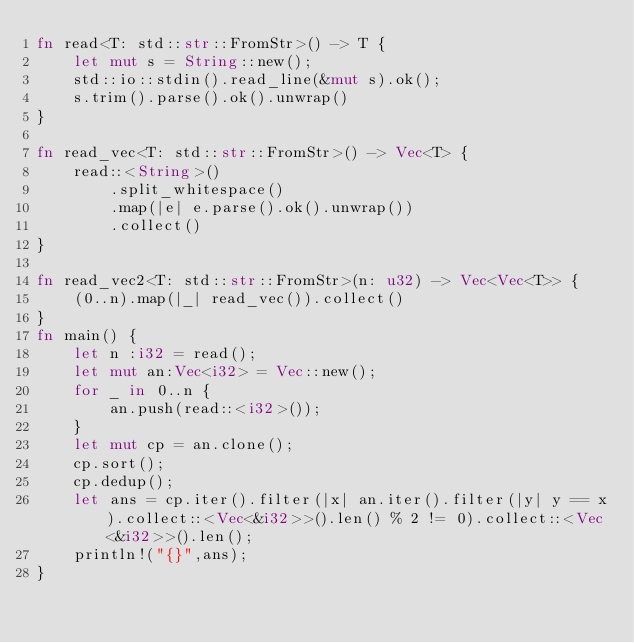Convert code to text. <code><loc_0><loc_0><loc_500><loc_500><_Rust_>fn read<T: std::str::FromStr>() -> T {
    let mut s = String::new();
    std::io::stdin().read_line(&mut s).ok();
    s.trim().parse().ok().unwrap()
}

fn read_vec<T: std::str::FromStr>() -> Vec<T> {
    read::<String>()
        .split_whitespace()
        .map(|e| e.parse().ok().unwrap())
        .collect()
}

fn read_vec2<T: std::str::FromStr>(n: u32) -> Vec<Vec<T>> {
    (0..n).map(|_| read_vec()).collect()
}
fn main() {
    let n :i32 = read();
    let mut an:Vec<i32> = Vec::new();
    for _ in 0..n {
        an.push(read::<i32>());
    }
    let mut cp = an.clone();
    cp.sort();
    cp.dedup();
    let ans = cp.iter().filter(|x| an.iter().filter(|y| y == x).collect::<Vec<&i32>>().len() % 2 != 0).collect::<Vec<&i32>>().len();
    println!("{}",ans);
}</code> 